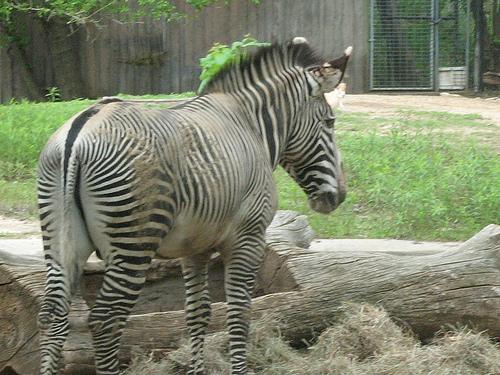Is this zebra covered in dirt?
Answer briefly. Yes. How many more zebra are there other than this one?
Give a very brief answer. 0. Is this zebra in captivity?
Give a very brief answer. Yes. 